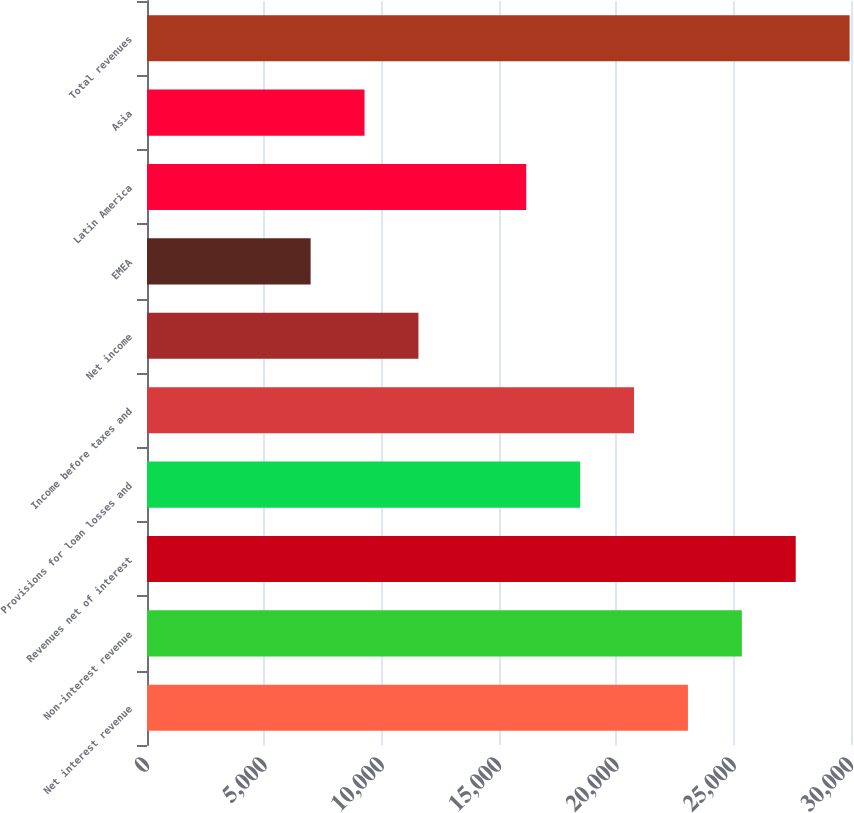Convert chart to OTSL. <chart><loc_0><loc_0><loc_500><loc_500><bar_chart><fcel>Net interest revenue<fcel>Non-interest revenue<fcel>Revenues net of interest<fcel>Provisions for loan losses and<fcel>Income before taxes and<fcel>Net income<fcel>EMEA<fcel>Latin America<fcel>Asia<fcel>Total revenues<nl><fcel>23051<fcel>25347.9<fcel>27644.7<fcel>18457.3<fcel>20754.1<fcel>11566.6<fcel>6972.91<fcel>16160.4<fcel>9269.78<fcel>29941.6<nl></chart> 